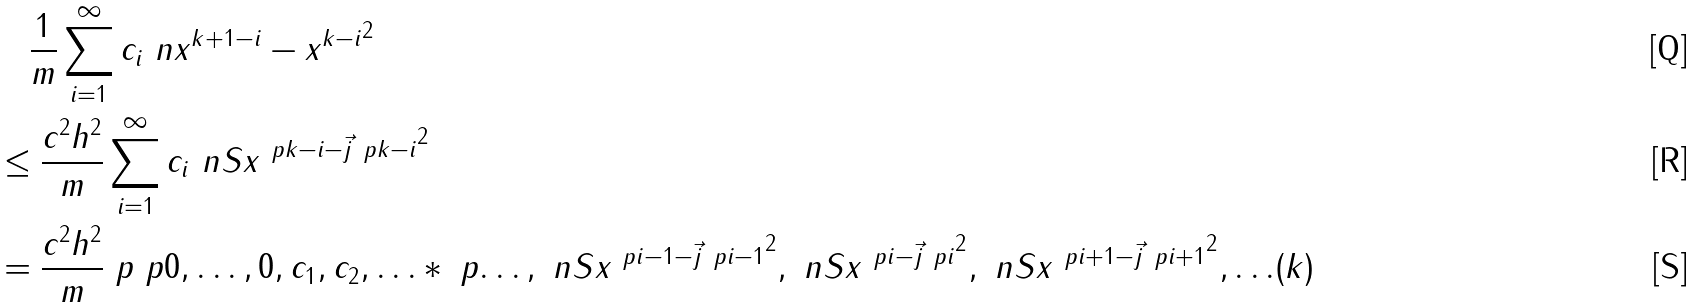<formula> <loc_0><loc_0><loc_500><loc_500>& \quad \frac { 1 } { m } \sum _ { i = 1 } ^ { \infty } c _ { i } \ n { x ^ { k + 1 - i } - x ^ { k - i } } ^ { 2 } \\ & \leq \frac { c ^ { 2 } h ^ { 2 } } { m } \sum _ { i = 1 } ^ { \infty } c _ { i } \ n { S x ^ { \ p { k - i } - \vec { j } \ p { k - i } } } ^ { 2 } \\ & = \frac { c ^ { 2 } h ^ { 2 } } { m } \ p { \ p { 0 , \dots , 0 , c _ { 1 } , c _ { 2 } , \dots } * \ p { \dots , \ n { S x ^ { \ p { i - 1 } - \vec { j } \ p { i - 1 } } } ^ { 2 } , \ n { S x ^ { \ p { i } - \vec { j } \ p { i } } } ^ { 2 } , \ n { S x ^ { \ p { i + 1 } - \vec { j } \ p { i + 1 } } } ^ { 2 } , \dots } } ( k )</formula> 